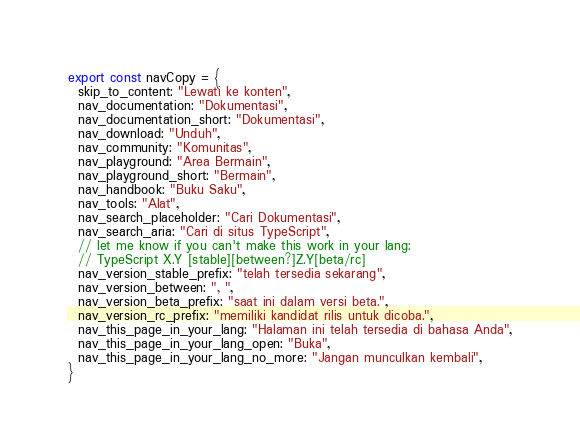<code> <loc_0><loc_0><loc_500><loc_500><_TypeScript_>export const navCopy = {
  skip_to_content: "Lewati ke konten",
  nav_documentation: "Dokumentasi",
  nav_documentation_short: "Dokumentasi",
  nav_download: "Unduh",
  nav_community: "Komunitas",
  nav_playground: "Area Bermain",
  nav_playground_short: "Bermain",
  nav_handbook: "Buku Saku",
  nav_tools: "Alat",
  nav_search_placeholder: "Cari Dokumentasi",
  nav_search_aria: "Cari di situs TypeScript",
  // let me know if you can't make this work in your lang:
  // TypeScript X.Y [stable][between?]Z.Y[beta/rc]
  nav_version_stable_prefix: "telah tersedia sekarang",
  nav_version_between: ", ",
  nav_version_beta_prefix: "saat ini dalam versi beta.",
  nav_version_rc_prefix: "memiliki kandidat rilis untuk dicoba.",
  nav_this_page_in_your_lang: "Halaman ini telah tersedia di bahasa Anda",
  nav_this_page_in_your_lang_open: "Buka",
  nav_this_page_in_your_lang_no_more: "Jangan munculkan kembali",
}
</code> 